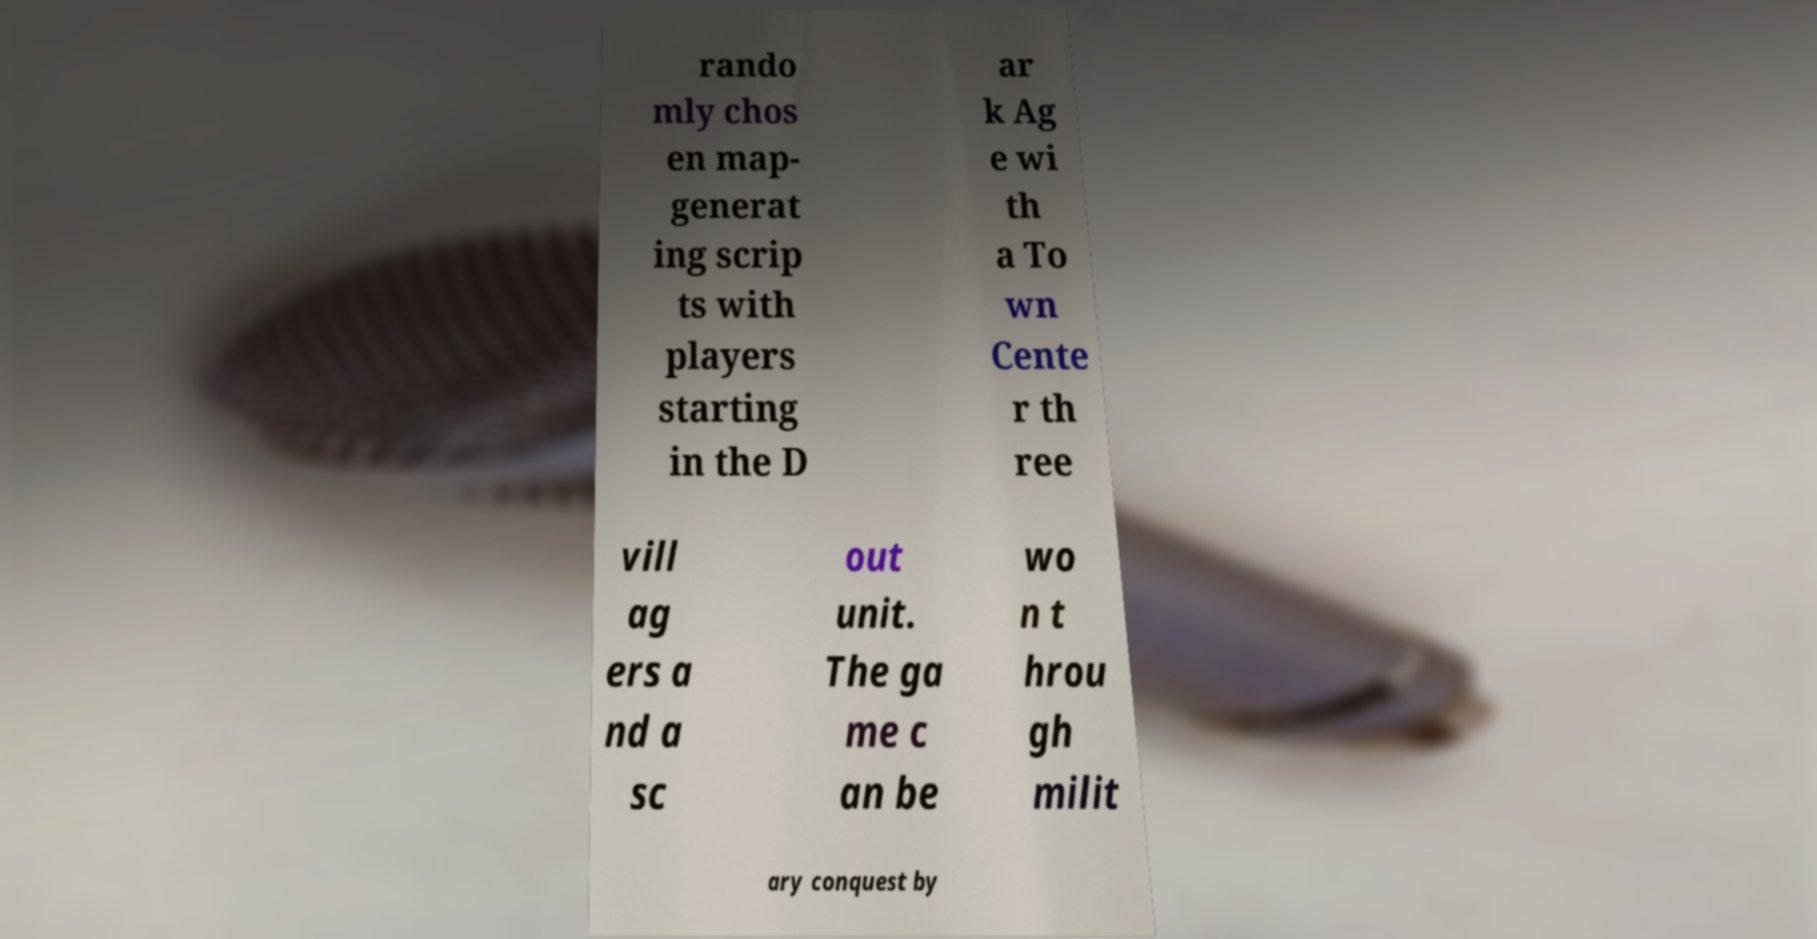There's text embedded in this image that I need extracted. Can you transcribe it verbatim? rando mly chos en map- generat ing scrip ts with players starting in the D ar k Ag e wi th a To wn Cente r th ree vill ag ers a nd a sc out unit. The ga me c an be wo n t hrou gh milit ary conquest by 